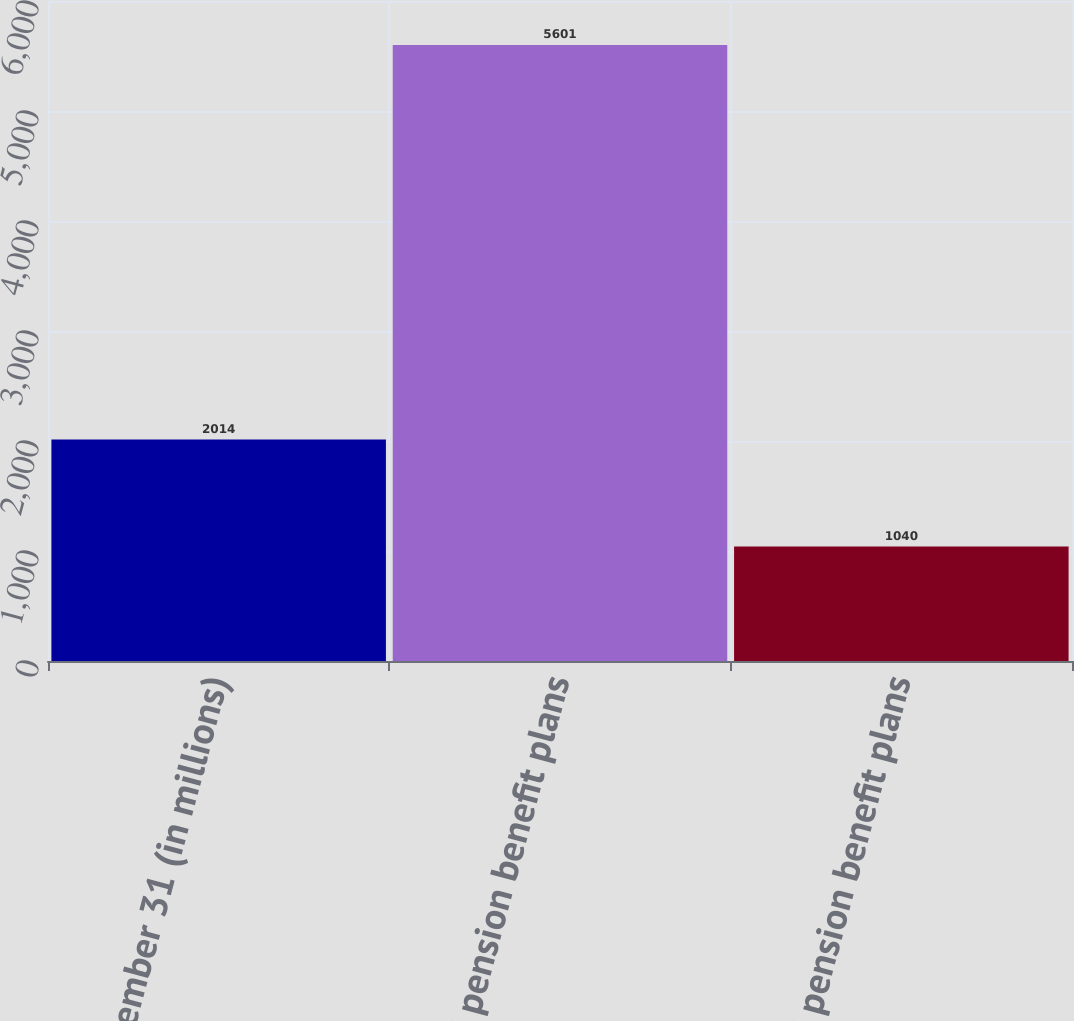<chart> <loc_0><loc_0><loc_500><loc_500><bar_chart><fcel>At December 31 (in millions)<fcel>US pension benefit plans<fcel>Non-US pension benefit plans<nl><fcel>2014<fcel>5601<fcel>1040<nl></chart> 